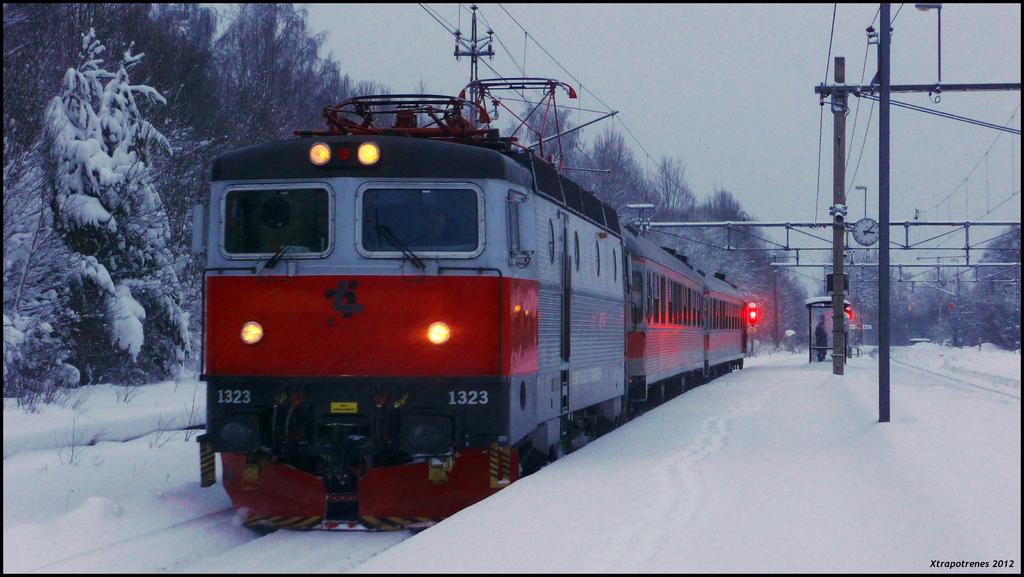What type of vehicle is in the image? There is a red train in the image. What is the train doing in the image? The train is moving on a track. What is the ground condition in front of the train? There is snow on the ground in front of the train. What can be seen behind the train? There are dry trees visible behind the train. What structures are present in the background? There is an iron frame and cables in the background. What type of grip does the train use to hold the quill while writing on the can? There is no quill or can present in the image, and the train is not writing anything. 